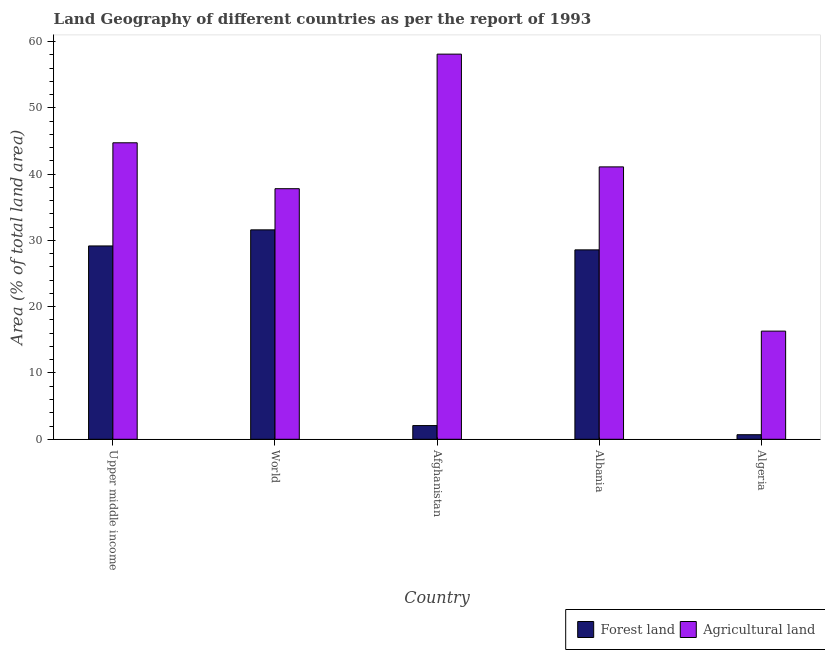Are the number of bars on each tick of the X-axis equal?
Provide a short and direct response. Yes. How many bars are there on the 3rd tick from the right?
Make the answer very short. 2. What is the percentage of land area under agriculture in Afghanistan?
Make the answer very short. 58.1. Across all countries, what is the maximum percentage of land area under agriculture?
Provide a succinct answer. 58.1. Across all countries, what is the minimum percentage of land area under forests?
Your answer should be very brief. 0.69. In which country was the percentage of land area under forests maximum?
Offer a terse response. World. In which country was the percentage of land area under agriculture minimum?
Your answer should be compact. Algeria. What is the total percentage of land area under agriculture in the graph?
Provide a short and direct response. 198.05. What is the difference between the percentage of land area under agriculture in Afghanistan and that in Albania?
Provide a succinct answer. 17.01. What is the difference between the percentage of land area under agriculture in Algeria and the percentage of land area under forests in Upper middle income?
Ensure brevity in your answer.  -12.85. What is the average percentage of land area under agriculture per country?
Keep it short and to the point. 39.61. What is the difference between the percentage of land area under agriculture and percentage of land area under forests in Albania?
Give a very brief answer. 12.52. In how many countries, is the percentage of land area under forests greater than 44 %?
Your response must be concise. 0. What is the ratio of the percentage of land area under agriculture in Albania to that in World?
Provide a short and direct response. 1.09. Is the percentage of land area under agriculture in Albania less than that in World?
Make the answer very short. No. Is the difference between the percentage of land area under forests in Albania and Upper middle income greater than the difference between the percentage of land area under agriculture in Albania and Upper middle income?
Offer a terse response. Yes. What is the difference between the highest and the second highest percentage of land area under agriculture?
Your answer should be very brief. 13.38. What is the difference between the highest and the lowest percentage of land area under agriculture?
Ensure brevity in your answer.  41.79. In how many countries, is the percentage of land area under forests greater than the average percentage of land area under forests taken over all countries?
Ensure brevity in your answer.  3. Is the sum of the percentage of land area under agriculture in Albania and Upper middle income greater than the maximum percentage of land area under forests across all countries?
Your response must be concise. Yes. What does the 1st bar from the left in Albania represents?
Keep it short and to the point. Forest land. What does the 2nd bar from the right in World represents?
Give a very brief answer. Forest land. How many bars are there?
Give a very brief answer. 10. How many countries are there in the graph?
Your response must be concise. 5. Does the graph contain any zero values?
Your response must be concise. No. What is the title of the graph?
Keep it short and to the point. Land Geography of different countries as per the report of 1993. What is the label or title of the X-axis?
Provide a succinct answer. Country. What is the label or title of the Y-axis?
Keep it short and to the point. Area (% of total land area). What is the Area (% of total land area) in Forest land in Upper middle income?
Ensure brevity in your answer.  29.17. What is the Area (% of total land area) in Agricultural land in Upper middle income?
Provide a succinct answer. 44.73. What is the Area (% of total land area) of Forest land in World?
Your answer should be compact. 31.59. What is the Area (% of total land area) in Agricultural land in World?
Make the answer very short. 37.8. What is the Area (% of total land area) in Forest land in Afghanistan?
Offer a very short reply. 2.07. What is the Area (% of total land area) of Agricultural land in Afghanistan?
Provide a short and direct response. 58.1. What is the Area (% of total land area) in Forest land in Albania?
Make the answer very short. 28.57. What is the Area (% of total land area) of Agricultural land in Albania?
Provide a short and direct response. 41.09. What is the Area (% of total land area) in Forest land in Algeria?
Offer a very short reply. 0.69. What is the Area (% of total land area) of Agricultural land in Algeria?
Keep it short and to the point. 16.32. Across all countries, what is the maximum Area (% of total land area) in Forest land?
Make the answer very short. 31.59. Across all countries, what is the maximum Area (% of total land area) in Agricultural land?
Make the answer very short. 58.1. Across all countries, what is the minimum Area (% of total land area) in Forest land?
Ensure brevity in your answer.  0.69. Across all countries, what is the minimum Area (% of total land area) of Agricultural land?
Your answer should be compact. 16.32. What is the total Area (% of total land area) in Forest land in the graph?
Provide a succinct answer. 92.09. What is the total Area (% of total land area) of Agricultural land in the graph?
Your answer should be very brief. 198.05. What is the difference between the Area (% of total land area) of Forest land in Upper middle income and that in World?
Your answer should be compact. -2.43. What is the difference between the Area (% of total land area) in Agricultural land in Upper middle income and that in World?
Make the answer very short. 6.93. What is the difference between the Area (% of total land area) of Forest land in Upper middle income and that in Afghanistan?
Keep it short and to the point. 27.1. What is the difference between the Area (% of total land area) in Agricultural land in Upper middle income and that in Afghanistan?
Make the answer very short. -13.38. What is the difference between the Area (% of total land area) in Forest land in Upper middle income and that in Albania?
Provide a short and direct response. 0.59. What is the difference between the Area (% of total land area) of Agricultural land in Upper middle income and that in Albania?
Your answer should be very brief. 3.63. What is the difference between the Area (% of total land area) of Forest land in Upper middle income and that in Algeria?
Your answer should be compact. 28.48. What is the difference between the Area (% of total land area) in Agricultural land in Upper middle income and that in Algeria?
Provide a short and direct response. 28.41. What is the difference between the Area (% of total land area) in Forest land in World and that in Afghanistan?
Your response must be concise. 29.53. What is the difference between the Area (% of total land area) of Agricultural land in World and that in Afghanistan?
Make the answer very short. -20.3. What is the difference between the Area (% of total land area) of Forest land in World and that in Albania?
Offer a very short reply. 3.02. What is the difference between the Area (% of total land area) of Agricultural land in World and that in Albania?
Make the answer very short. -3.29. What is the difference between the Area (% of total land area) in Forest land in World and that in Algeria?
Provide a succinct answer. 30.91. What is the difference between the Area (% of total land area) in Agricultural land in World and that in Algeria?
Offer a terse response. 21.49. What is the difference between the Area (% of total land area) of Forest land in Afghanistan and that in Albania?
Offer a very short reply. -26.51. What is the difference between the Area (% of total land area) in Agricultural land in Afghanistan and that in Albania?
Keep it short and to the point. 17.01. What is the difference between the Area (% of total land area) of Forest land in Afghanistan and that in Algeria?
Keep it short and to the point. 1.38. What is the difference between the Area (% of total land area) in Agricultural land in Afghanistan and that in Algeria?
Provide a short and direct response. 41.79. What is the difference between the Area (% of total land area) of Forest land in Albania and that in Algeria?
Make the answer very short. 27.89. What is the difference between the Area (% of total land area) of Agricultural land in Albania and that in Algeria?
Offer a very short reply. 24.78. What is the difference between the Area (% of total land area) of Forest land in Upper middle income and the Area (% of total land area) of Agricultural land in World?
Provide a short and direct response. -8.64. What is the difference between the Area (% of total land area) in Forest land in Upper middle income and the Area (% of total land area) in Agricultural land in Afghanistan?
Offer a terse response. -28.94. What is the difference between the Area (% of total land area) of Forest land in Upper middle income and the Area (% of total land area) of Agricultural land in Albania?
Offer a terse response. -11.93. What is the difference between the Area (% of total land area) of Forest land in Upper middle income and the Area (% of total land area) of Agricultural land in Algeria?
Offer a terse response. 12.85. What is the difference between the Area (% of total land area) in Forest land in World and the Area (% of total land area) in Agricultural land in Afghanistan?
Your answer should be very brief. -26.51. What is the difference between the Area (% of total land area) of Forest land in World and the Area (% of total land area) of Agricultural land in Albania?
Keep it short and to the point. -9.5. What is the difference between the Area (% of total land area) of Forest land in World and the Area (% of total land area) of Agricultural land in Algeria?
Offer a very short reply. 15.28. What is the difference between the Area (% of total land area) of Forest land in Afghanistan and the Area (% of total land area) of Agricultural land in Albania?
Offer a very short reply. -39.03. What is the difference between the Area (% of total land area) in Forest land in Afghanistan and the Area (% of total land area) in Agricultural land in Algeria?
Make the answer very short. -14.25. What is the difference between the Area (% of total land area) of Forest land in Albania and the Area (% of total land area) of Agricultural land in Algeria?
Offer a very short reply. 12.26. What is the average Area (% of total land area) of Forest land per country?
Offer a very short reply. 18.42. What is the average Area (% of total land area) of Agricultural land per country?
Ensure brevity in your answer.  39.61. What is the difference between the Area (% of total land area) of Forest land and Area (% of total land area) of Agricultural land in Upper middle income?
Your answer should be very brief. -15.56. What is the difference between the Area (% of total land area) of Forest land and Area (% of total land area) of Agricultural land in World?
Keep it short and to the point. -6.21. What is the difference between the Area (% of total land area) of Forest land and Area (% of total land area) of Agricultural land in Afghanistan?
Offer a terse response. -56.04. What is the difference between the Area (% of total land area) of Forest land and Area (% of total land area) of Agricultural land in Albania?
Make the answer very short. -12.52. What is the difference between the Area (% of total land area) in Forest land and Area (% of total land area) in Agricultural land in Algeria?
Provide a short and direct response. -15.63. What is the ratio of the Area (% of total land area) of Forest land in Upper middle income to that in World?
Keep it short and to the point. 0.92. What is the ratio of the Area (% of total land area) of Agricultural land in Upper middle income to that in World?
Provide a succinct answer. 1.18. What is the ratio of the Area (% of total land area) in Forest land in Upper middle income to that in Afghanistan?
Keep it short and to the point. 14.11. What is the ratio of the Area (% of total land area) in Agricultural land in Upper middle income to that in Afghanistan?
Your answer should be compact. 0.77. What is the ratio of the Area (% of total land area) in Forest land in Upper middle income to that in Albania?
Keep it short and to the point. 1.02. What is the ratio of the Area (% of total land area) in Agricultural land in Upper middle income to that in Albania?
Your response must be concise. 1.09. What is the ratio of the Area (% of total land area) in Forest land in Upper middle income to that in Algeria?
Keep it short and to the point. 42.34. What is the ratio of the Area (% of total land area) of Agricultural land in Upper middle income to that in Algeria?
Provide a short and direct response. 2.74. What is the ratio of the Area (% of total land area) of Forest land in World to that in Afghanistan?
Your answer should be compact. 15.28. What is the ratio of the Area (% of total land area) in Agricultural land in World to that in Afghanistan?
Your answer should be very brief. 0.65. What is the ratio of the Area (% of total land area) of Forest land in World to that in Albania?
Offer a terse response. 1.11. What is the ratio of the Area (% of total land area) in Agricultural land in World to that in Albania?
Provide a succinct answer. 0.92. What is the ratio of the Area (% of total land area) in Forest land in World to that in Algeria?
Keep it short and to the point. 45.87. What is the ratio of the Area (% of total land area) of Agricultural land in World to that in Algeria?
Your answer should be very brief. 2.32. What is the ratio of the Area (% of total land area) in Forest land in Afghanistan to that in Albania?
Offer a terse response. 0.07. What is the ratio of the Area (% of total land area) of Agricultural land in Afghanistan to that in Albania?
Your answer should be very brief. 1.41. What is the ratio of the Area (% of total land area) in Forest land in Afghanistan to that in Algeria?
Provide a short and direct response. 3. What is the ratio of the Area (% of total land area) in Agricultural land in Afghanistan to that in Algeria?
Ensure brevity in your answer.  3.56. What is the ratio of the Area (% of total land area) of Forest land in Albania to that in Algeria?
Your response must be concise. 41.48. What is the ratio of the Area (% of total land area) in Agricultural land in Albania to that in Algeria?
Offer a very short reply. 2.52. What is the difference between the highest and the second highest Area (% of total land area) of Forest land?
Keep it short and to the point. 2.43. What is the difference between the highest and the second highest Area (% of total land area) in Agricultural land?
Provide a succinct answer. 13.38. What is the difference between the highest and the lowest Area (% of total land area) in Forest land?
Give a very brief answer. 30.91. What is the difference between the highest and the lowest Area (% of total land area) in Agricultural land?
Offer a very short reply. 41.79. 